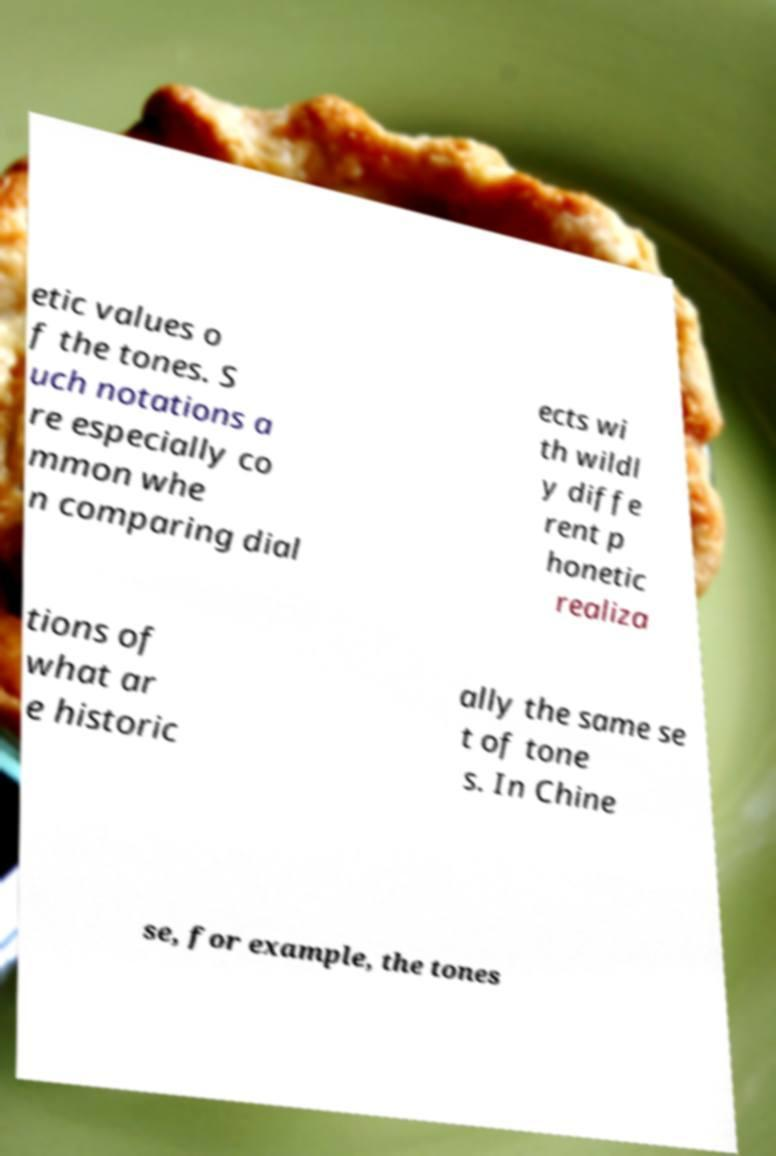For documentation purposes, I need the text within this image transcribed. Could you provide that? etic values o f the tones. S uch notations a re especially co mmon whe n comparing dial ects wi th wildl y diffe rent p honetic realiza tions of what ar e historic ally the same se t of tone s. In Chine se, for example, the tones 